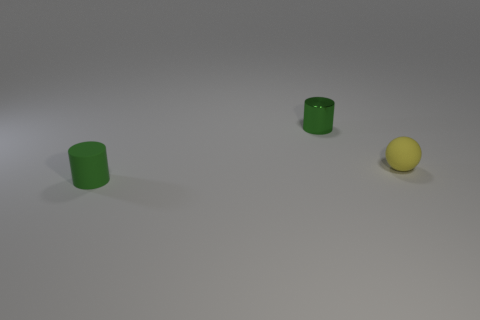Add 2 small yellow cylinders. How many objects exist? 5 Subtract all balls. How many objects are left? 2 Add 3 tiny green matte objects. How many tiny green matte objects exist? 4 Subtract 0 blue spheres. How many objects are left? 3 Subtract all big metal cylinders. Subtract all matte cylinders. How many objects are left? 2 Add 3 small yellow spheres. How many small yellow spheres are left? 4 